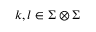Convert formula to latex. <formula><loc_0><loc_0><loc_500><loc_500>k , l \in \Sigma \otimes \Sigma</formula> 